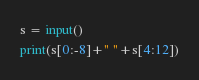<code> <loc_0><loc_0><loc_500><loc_500><_Python_>s = input()
print(s[0:-8]+" "+s[4:12])</code> 